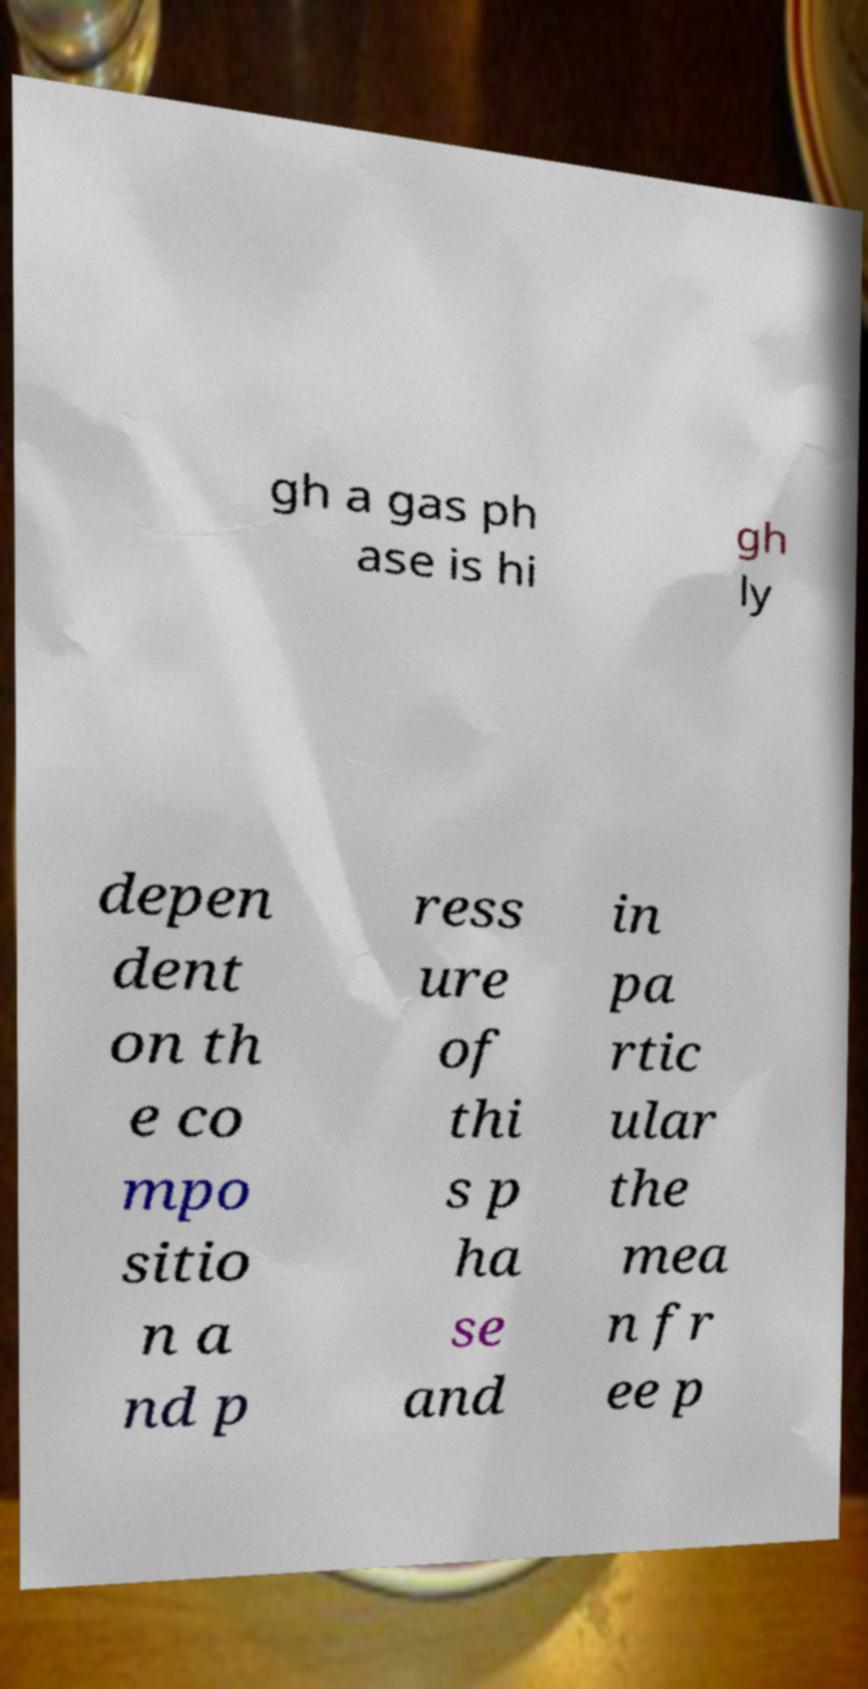Please read and relay the text visible in this image. What does it say? gh a gas ph ase is hi gh ly depen dent on th e co mpo sitio n a nd p ress ure of thi s p ha se and in pa rtic ular the mea n fr ee p 